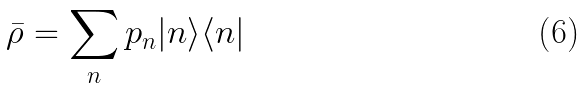Convert formula to latex. <formula><loc_0><loc_0><loc_500><loc_500>\bar { \rho } = \sum _ { n } p _ { n } | n \rangle \langle n |</formula> 